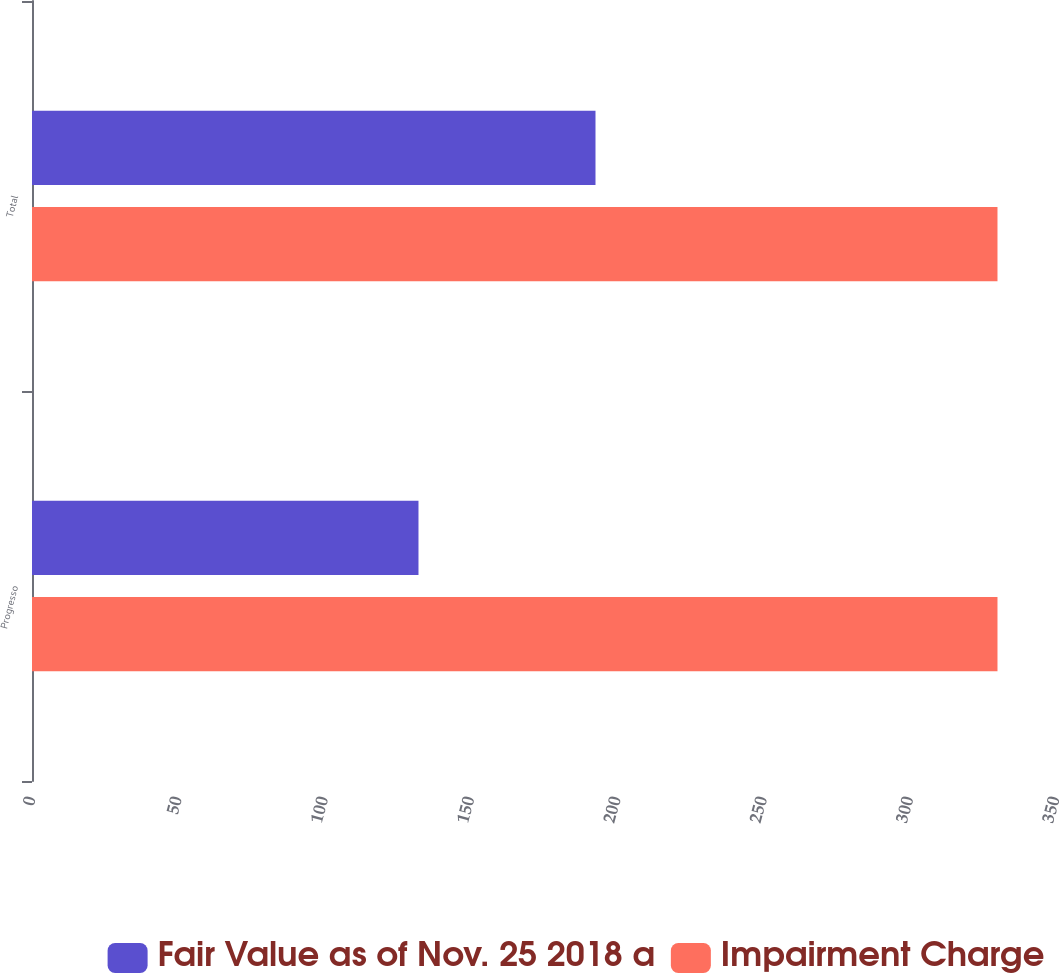Convert chart. <chart><loc_0><loc_0><loc_500><loc_500><stacked_bar_chart><ecel><fcel>Progresso<fcel>Total<nl><fcel>Fair Value as of Nov. 25 2018 a<fcel>132.1<fcel>192.6<nl><fcel>Impairment Charge<fcel>330<fcel>330<nl></chart> 